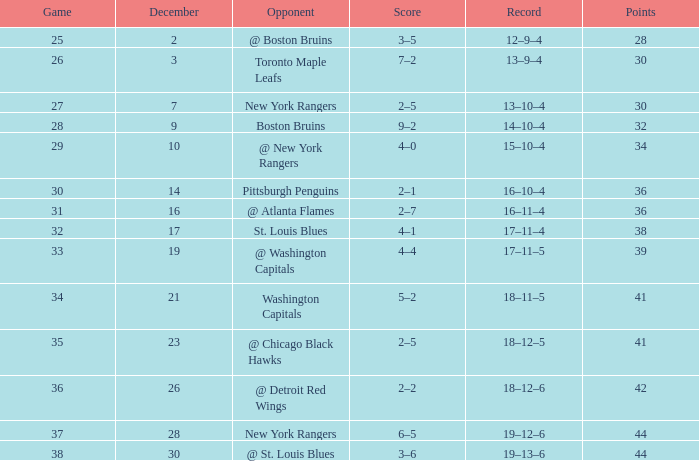What score includes 36 points and a 30-game competition? 2–1. 